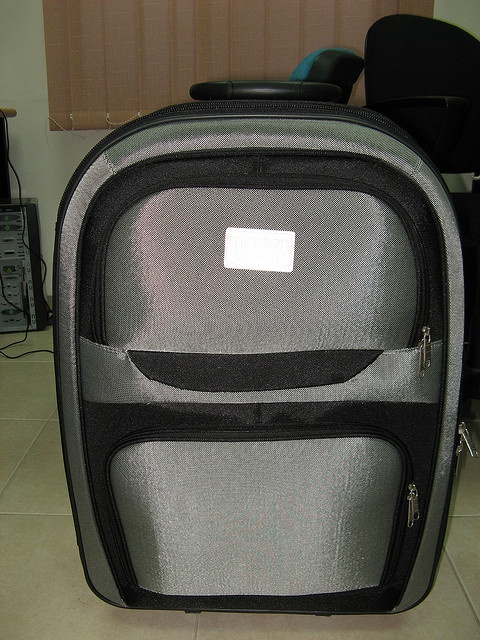Describe the objects in this image and their specific colors. I can see a suitcase in gray, black, and darkgray tones in this image. 